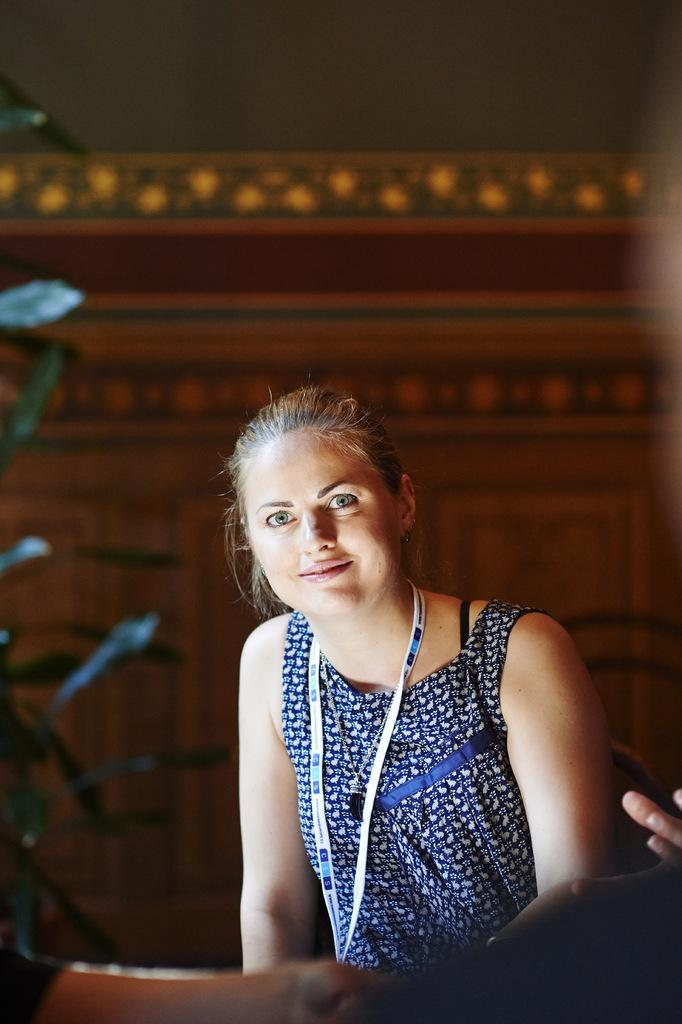What is the lady in the image doing? The lady is sitting in the image. What is the lady wearing on her upper body? The lady is wearing a blue top. What can be seen around the lady's neck? The lady has an ID card around her neck. What type of vegetation is visible in the background of the image? There is a plant in the background of the image. What type of soup is being served in the image? There is no soup present in the image; it features a lady sitting with a plant in the background. Can you tell me how many corn cobs are visible in the image? There is: There is no corn present in the image. 